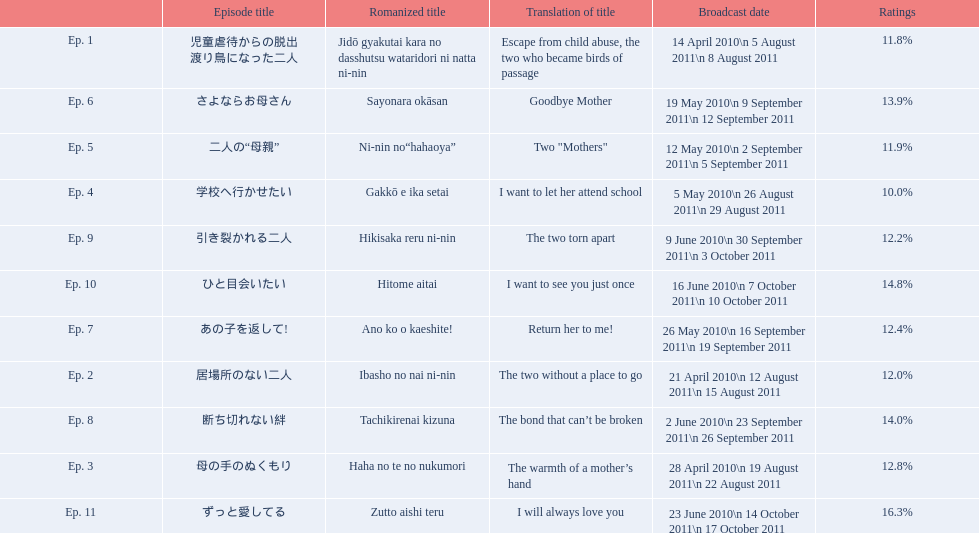Which episode had the highest ratings? Ep. 11. Which episode was named haha no te no nukumori? Ep. 3. Besides episode 10 which episode had a 14% rating? Ep. 8. 